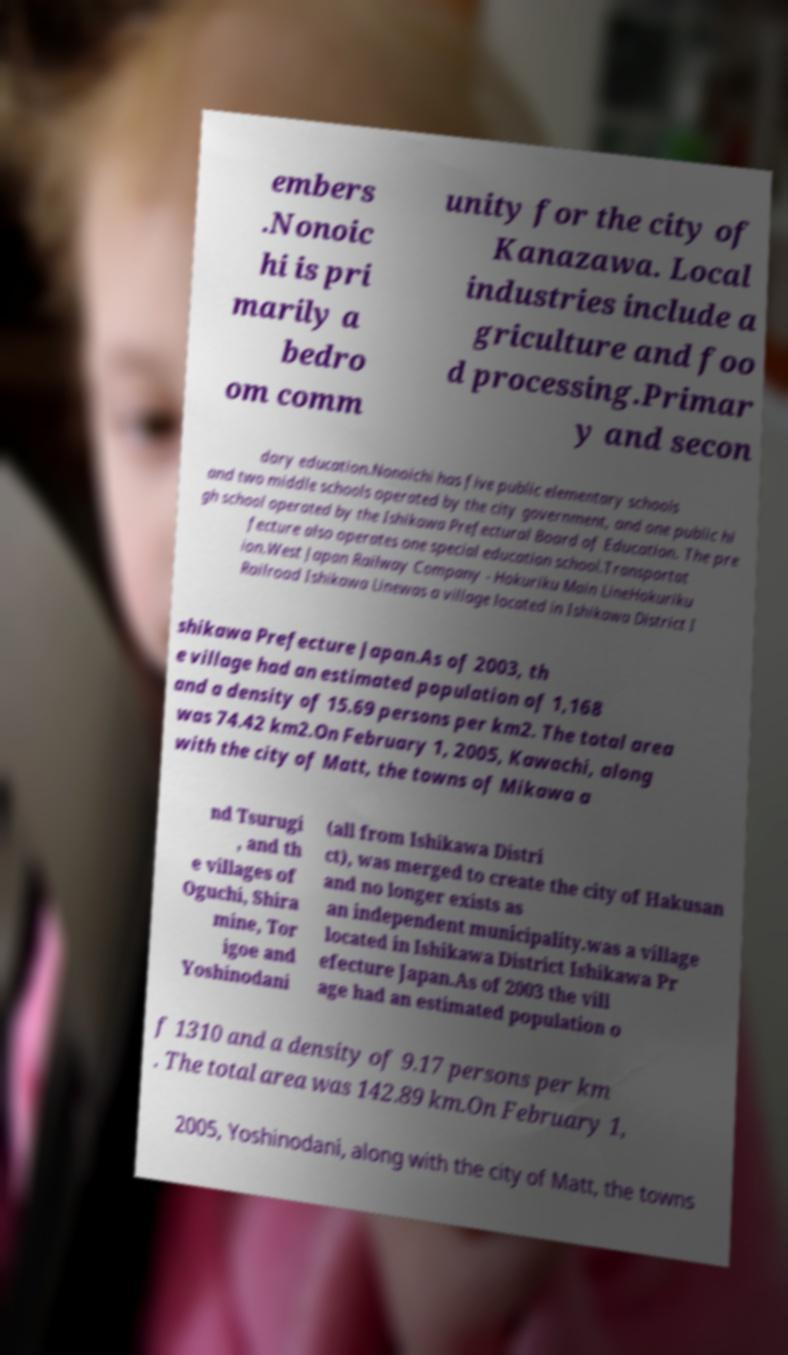I need the written content from this picture converted into text. Can you do that? embers .Nonoic hi is pri marily a bedro om comm unity for the city of Kanazawa. Local industries include a griculture and foo d processing.Primar y and secon dary education.Nonoichi has five public elementary schools and two middle schools operated by the city government, and one public hi gh school operated by the Ishikawa Prefectural Board of Education. The pre fecture also operates one special education school.Transportat ion.West Japan Railway Company - Hokuriku Main LineHokuriku Railroad Ishikawa Linewas a village located in Ishikawa District I shikawa Prefecture Japan.As of 2003, th e village had an estimated population of 1,168 and a density of 15.69 persons per km2. The total area was 74.42 km2.On February 1, 2005, Kawachi, along with the city of Matt, the towns of Mikawa a nd Tsurugi , and th e villages of Oguchi, Shira mine, Tor igoe and Yoshinodani (all from Ishikawa Distri ct), was merged to create the city of Hakusan and no longer exists as an independent municipality.was a village located in Ishikawa District Ishikawa Pr efecture Japan.As of 2003 the vill age had an estimated population o f 1310 and a density of 9.17 persons per km . The total area was 142.89 km.On February 1, 2005, Yoshinodani, along with the city of Matt, the towns 